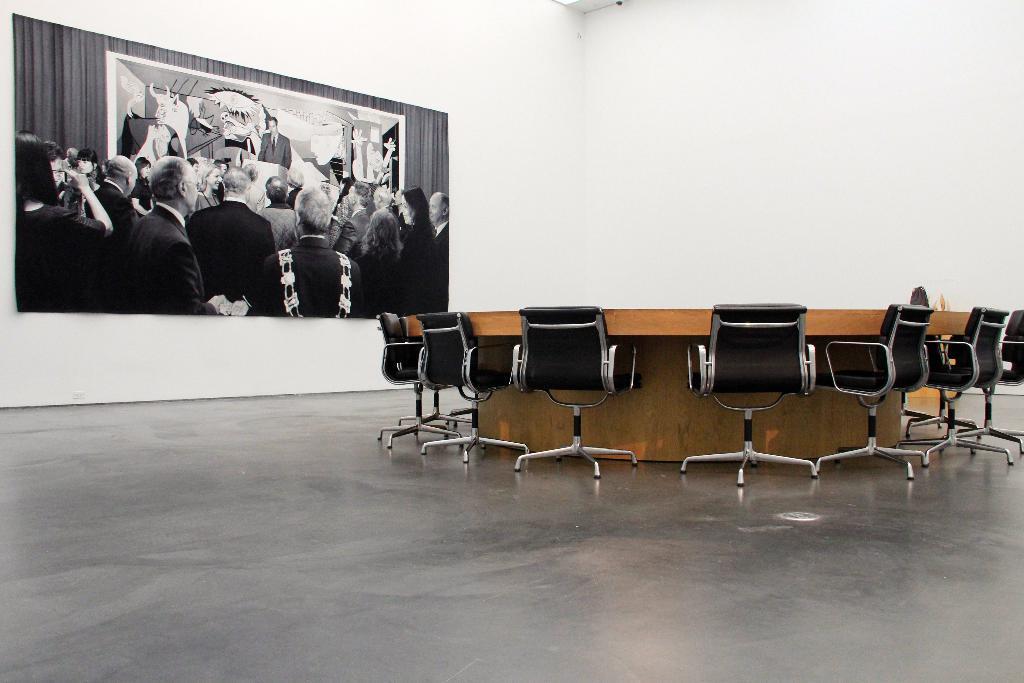Can you describe this image briefly? This is an inside view of a room. On the right side there is a table and there are chairs around it. On the left side there is a photo frame attached to the wall. This photo frame consists of a black and white picture. In this picture, I can see a crowd of people facing towards the back side. In the background one man is standing in front of the podium. At the back of this man there is a poster and a curtain. 